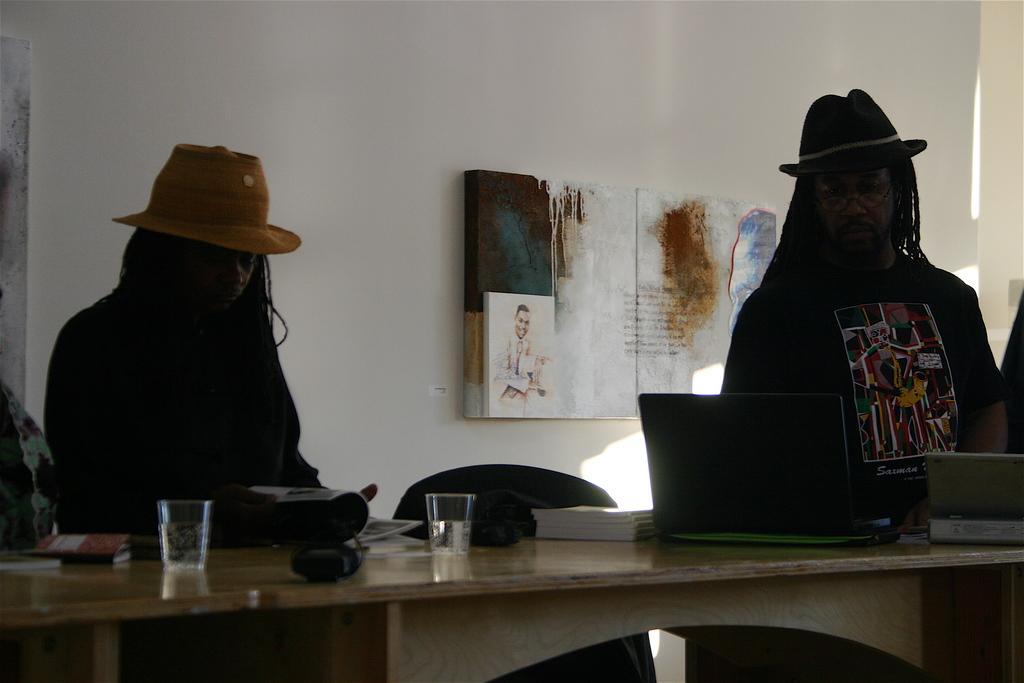Could you give a brief overview of what you see in this image? In this image I can see there are two men who are wearing a hat on the head and standing in front of the table. On the table we have a laptop, couple of glasses and other objects on it. Behind these people we have a white wall with a poster on it. 